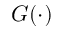Convert formula to latex. <formula><loc_0><loc_0><loc_500><loc_500>G ( \cdot )</formula> 